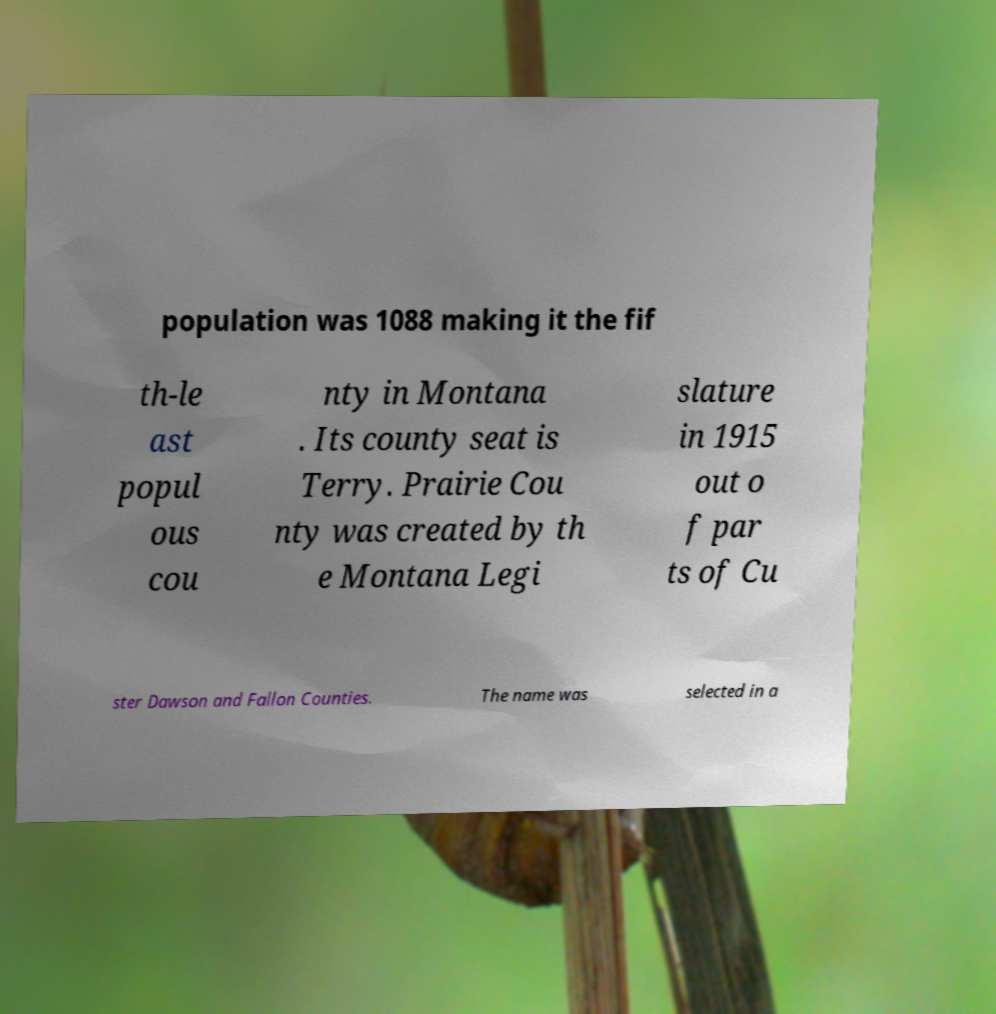There's text embedded in this image that I need extracted. Can you transcribe it verbatim? population was 1088 making it the fif th-le ast popul ous cou nty in Montana . Its county seat is Terry. Prairie Cou nty was created by th e Montana Legi slature in 1915 out o f par ts of Cu ster Dawson and Fallon Counties. The name was selected in a 